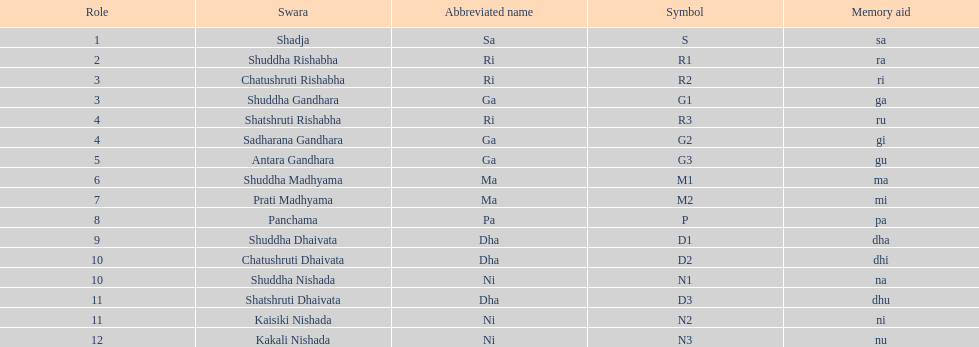List each pair of swaras that share the same position. Chatushruti Rishabha, Shuddha Gandhara, Shatshruti Rishabha, Sadharana Gandhara, Chatushruti Dhaivata, Shuddha Nishada, Shatshruti Dhaivata, Kaisiki Nishada. 